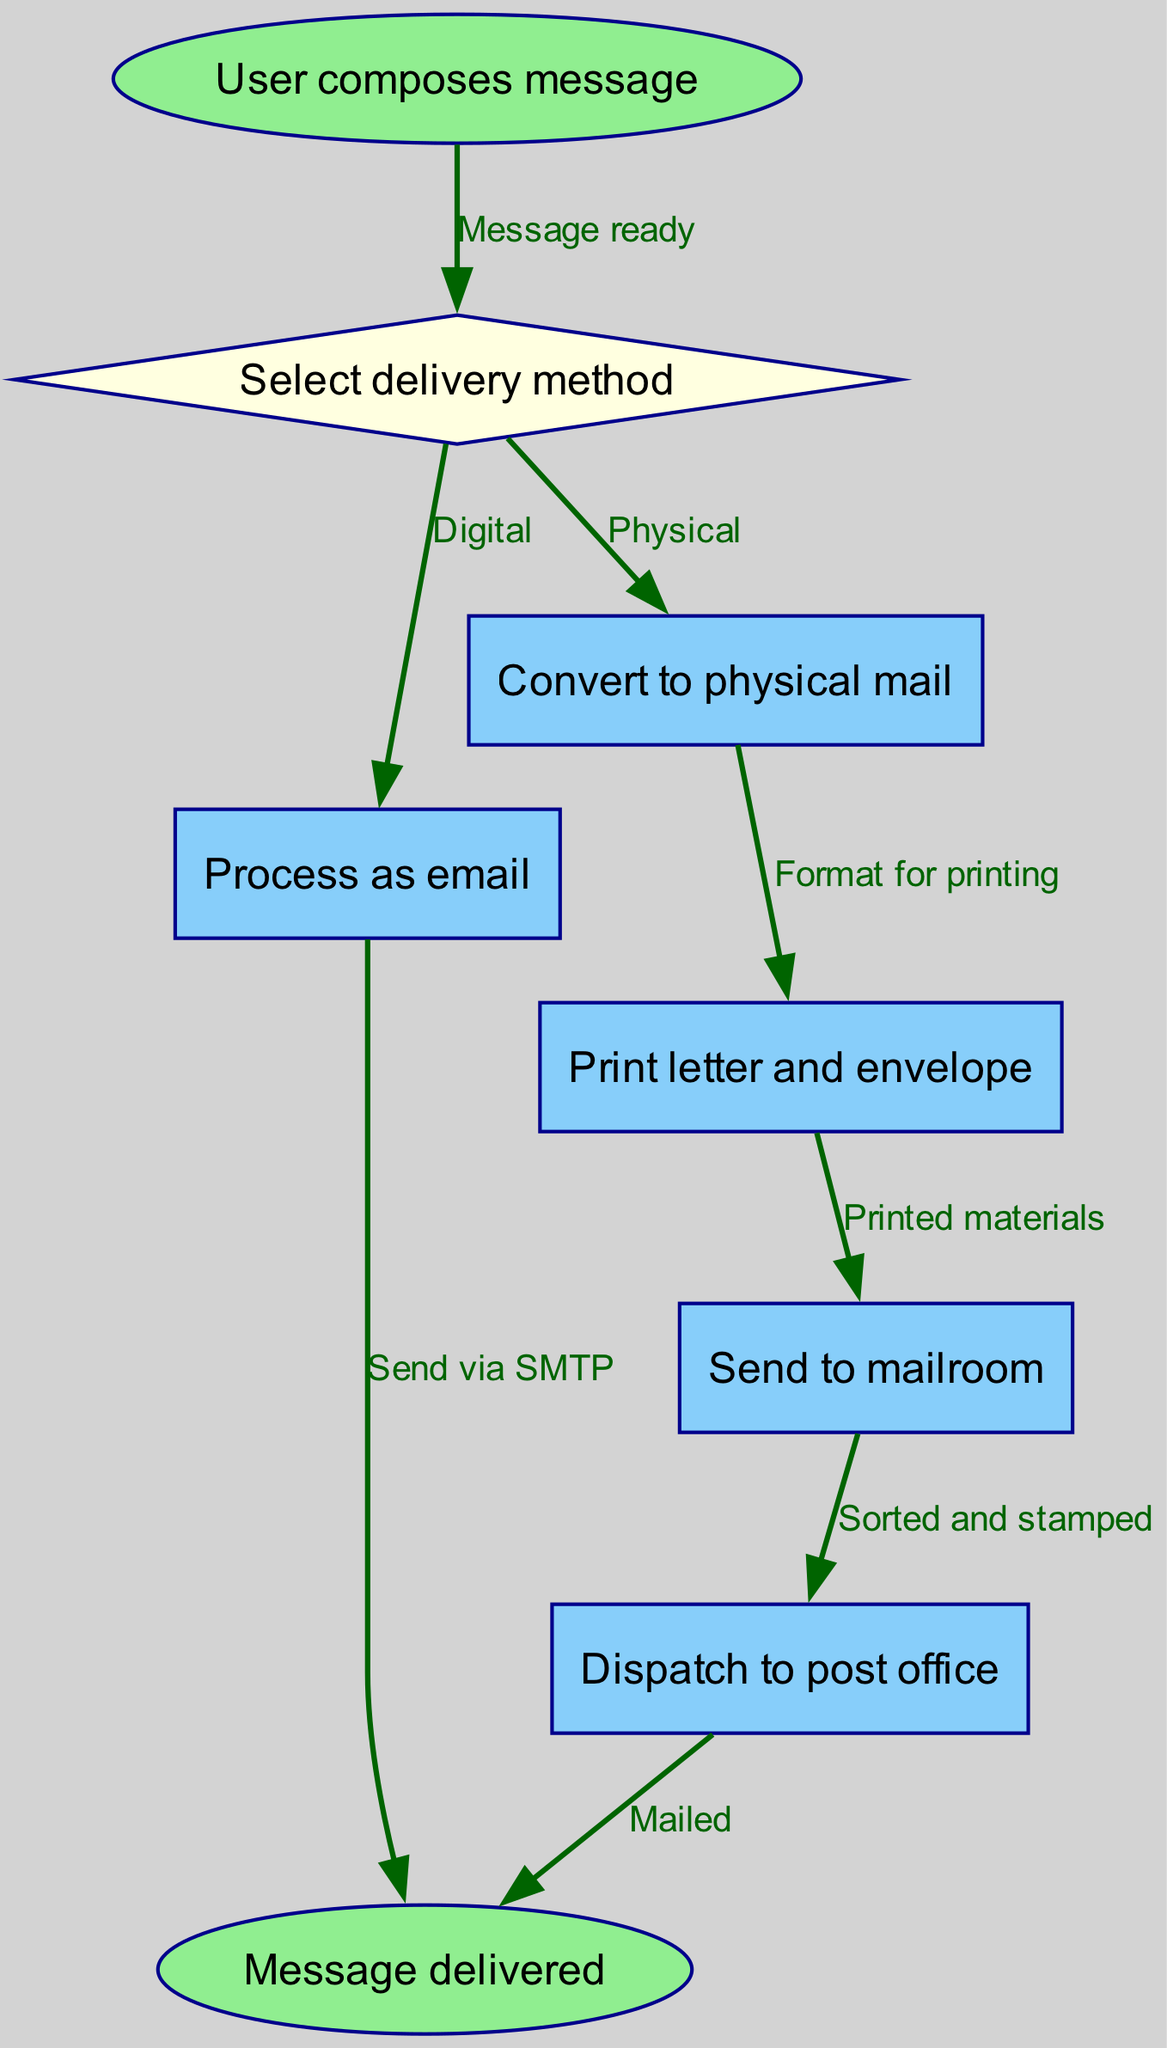What is the first step of the process? The diagram starts with the node labeled "User composes message," which indicates that the user's action to create a message marks the beginning of the process.
Answer: User composes message How many nodes are in the diagram? The diagram consists of 8 nodes representing different steps or decisions within the process, starting from the user composing a message to the message being delivered.
Answer: 8 What are the two delivery methods presented in the diagram? The diagram shows a choice node where users can select between "Digital" for email and "Physical" for physical mail as their delivery method.
Answer: Digital, Physical What happens if the user selects "Digital"? If the user selects "Digital," the process moves to the "Process as email" node, where it continues to send the message via SMTP, leading directly to the end of the process.
Answer: Send via SMTP What is the last action in the physical mail delivery method? After the physical mail is processed and dispatched, the last action depicted in the diagram is "Mailed," which indicates the message has been sent out via the post office.
Answer: Mailed How many edges are there in the diagram? The diagram contains 7 edges that represent the connections between the nodes, illustrating the flow from one step to another in the hybrid email-physical mail system.
Answer: 7 What is the node that indicates a decision point in the process? The diagram features a decision point represented by the diamond-shaped node labeled "Select delivery method," where users must choose between delivery options.
Answer: Select delivery method List the steps that follow if the user chooses Physical. If the user selects Physical, the flow goes from "Convert to physical mail" to "Print letter and envelope," then to "Send to mailroom," followed by "Dispatch to post office," and finally ends with "Message delivered."
Answer: Print letter and envelope, Send to mailroom, Dispatch to post office, Message delivered 